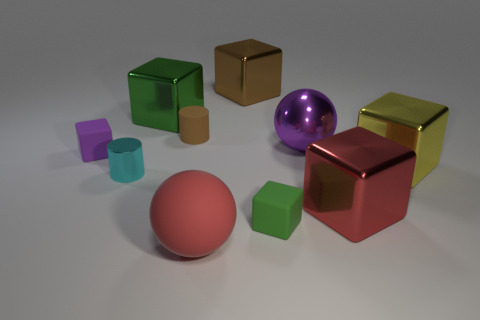Do the red sphere and the cylinder left of the green metallic block have the same material?
Provide a succinct answer. No. The red object behind the large matte sphere left of the big red cube is what shape?
Provide a succinct answer. Cube. How many small objects are either purple blocks or cyan metallic things?
Give a very brief answer. 2. What number of red metallic objects have the same shape as the small purple thing?
Offer a very short reply. 1. There is a brown rubber thing; is its shape the same as the shiny object that is left of the large green metal object?
Your answer should be compact. Yes. What number of yellow shiny blocks are in front of the purple rubber cube?
Give a very brief answer. 1. Are there any other cylinders that have the same size as the metallic cylinder?
Give a very brief answer. Yes. There is a green object behind the small cyan cylinder; is it the same shape as the large yellow object?
Make the answer very short. Yes. The small shiny thing has what color?
Provide a succinct answer. Cyan. Is there a cyan metal object?
Provide a succinct answer. Yes. 